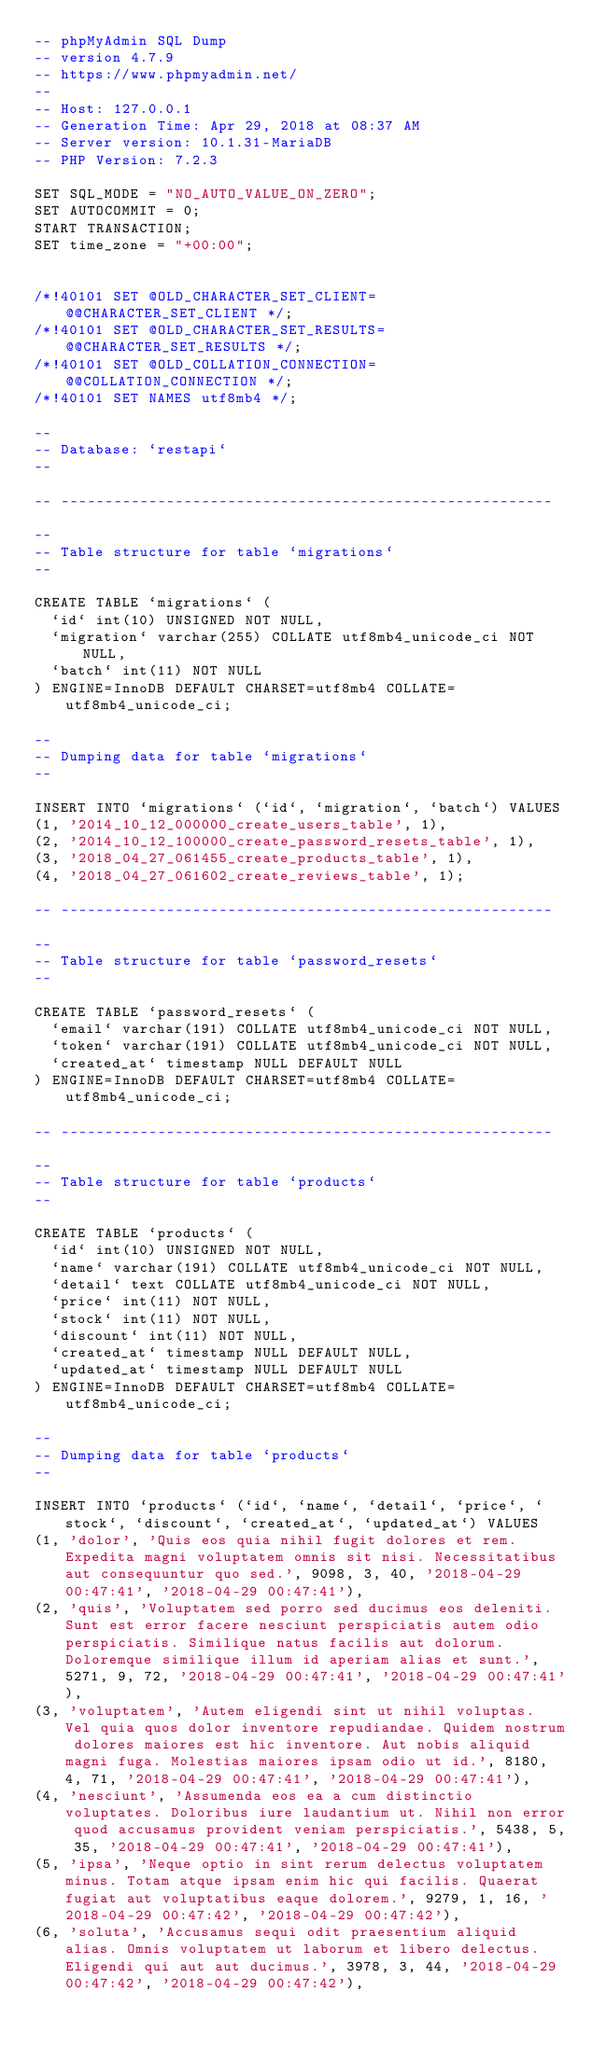Convert code to text. <code><loc_0><loc_0><loc_500><loc_500><_SQL_>-- phpMyAdmin SQL Dump
-- version 4.7.9
-- https://www.phpmyadmin.net/
--
-- Host: 127.0.0.1
-- Generation Time: Apr 29, 2018 at 08:37 AM
-- Server version: 10.1.31-MariaDB
-- PHP Version: 7.2.3

SET SQL_MODE = "NO_AUTO_VALUE_ON_ZERO";
SET AUTOCOMMIT = 0;
START TRANSACTION;
SET time_zone = "+00:00";


/*!40101 SET @OLD_CHARACTER_SET_CLIENT=@@CHARACTER_SET_CLIENT */;
/*!40101 SET @OLD_CHARACTER_SET_RESULTS=@@CHARACTER_SET_RESULTS */;
/*!40101 SET @OLD_COLLATION_CONNECTION=@@COLLATION_CONNECTION */;
/*!40101 SET NAMES utf8mb4 */;

--
-- Database: `restapi`
--

-- --------------------------------------------------------

--
-- Table structure for table `migrations`
--

CREATE TABLE `migrations` (
  `id` int(10) UNSIGNED NOT NULL,
  `migration` varchar(255) COLLATE utf8mb4_unicode_ci NOT NULL,
  `batch` int(11) NOT NULL
) ENGINE=InnoDB DEFAULT CHARSET=utf8mb4 COLLATE=utf8mb4_unicode_ci;

--
-- Dumping data for table `migrations`
--

INSERT INTO `migrations` (`id`, `migration`, `batch`) VALUES
(1, '2014_10_12_000000_create_users_table', 1),
(2, '2014_10_12_100000_create_password_resets_table', 1),
(3, '2018_04_27_061455_create_products_table', 1),
(4, '2018_04_27_061602_create_reviews_table', 1);

-- --------------------------------------------------------

--
-- Table structure for table `password_resets`
--

CREATE TABLE `password_resets` (
  `email` varchar(191) COLLATE utf8mb4_unicode_ci NOT NULL,
  `token` varchar(191) COLLATE utf8mb4_unicode_ci NOT NULL,
  `created_at` timestamp NULL DEFAULT NULL
) ENGINE=InnoDB DEFAULT CHARSET=utf8mb4 COLLATE=utf8mb4_unicode_ci;

-- --------------------------------------------------------

--
-- Table structure for table `products`
--

CREATE TABLE `products` (
  `id` int(10) UNSIGNED NOT NULL,
  `name` varchar(191) COLLATE utf8mb4_unicode_ci NOT NULL,
  `detail` text COLLATE utf8mb4_unicode_ci NOT NULL,
  `price` int(11) NOT NULL,
  `stock` int(11) NOT NULL,
  `discount` int(11) NOT NULL,
  `created_at` timestamp NULL DEFAULT NULL,
  `updated_at` timestamp NULL DEFAULT NULL
) ENGINE=InnoDB DEFAULT CHARSET=utf8mb4 COLLATE=utf8mb4_unicode_ci;

--
-- Dumping data for table `products`
--

INSERT INTO `products` (`id`, `name`, `detail`, `price`, `stock`, `discount`, `created_at`, `updated_at`) VALUES
(1, 'dolor', 'Quis eos quia nihil fugit dolores et rem. Expedita magni voluptatem omnis sit nisi. Necessitatibus aut consequuntur quo sed.', 9098, 3, 40, '2018-04-29 00:47:41', '2018-04-29 00:47:41'),
(2, 'quis', 'Voluptatem sed porro sed ducimus eos deleniti. Sunt est error facere nesciunt perspiciatis autem odio perspiciatis. Similique natus facilis aut dolorum. Doloremque similique illum id aperiam alias et sunt.', 5271, 9, 72, '2018-04-29 00:47:41', '2018-04-29 00:47:41'),
(3, 'voluptatem', 'Autem eligendi sint ut nihil voluptas. Vel quia quos dolor inventore repudiandae. Quidem nostrum dolores maiores est hic inventore. Aut nobis aliquid magni fuga. Molestias maiores ipsam odio ut id.', 8180, 4, 71, '2018-04-29 00:47:41', '2018-04-29 00:47:41'),
(4, 'nesciunt', 'Assumenda eos ea a cum distinctio voluptates. Doloribus iure laudantium ut. Nihil non error quod accusamus provident veniam perspiciatis.', 5438, 5, 35, '2018-04-29 00:47:41', '2018-04-29 00:47:41'),
(5, 'ipsa', 'Neque optio in sint rerum delectus voluptatem minus. Totam atque ipsam enim hic qui facilis. Quaerat fugiat aut voluptatibus eaque dolorem.', 9279, 1, 16, '2018-04-29 00:47:42', '2018-04-29 00:47:42'),
(6, 'soluta', 'Accusamus sequi odit praesentium aliquid alias. Omnis voluptatem ut laborum et libero delectus. Eligendi qui aut aut ducimus.', 3978, 3, 44, '2018-04-29 00:47:42', '2018-04-29 00:47:42'),</code> 